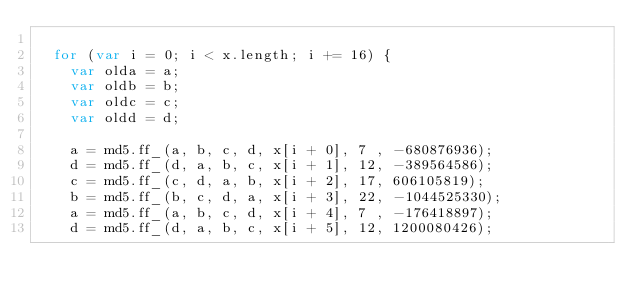Convert code to text. <code><loc_0><loc_0><loc_500><loc_500><_JavaScript_>
  for (var i = 0; i < x.length; i += 16) {
    var olda = a;
    var oldb = b;
    var oldc = c;
    var oldd = d;

    a = md5.ff_(a, b, c, d, x[i + 0], 7 , -680876936);
    d = md5.ff_(d, a, b, c, x[i + 1], 12, -389564586);
    c = md5.ff_(c, d, a, b, x[i + 2], 17, 606105819);
    b = md5.ff_(b, c, d, a, x[i + 3], 22, -1044525330);
    a = md5.ff_(a, b, c, d, x[i + 4], 7 , -176418897);
    d = md5.ff_(d, a, b, c, x[i + 5], 12, 1200080426);</code> 